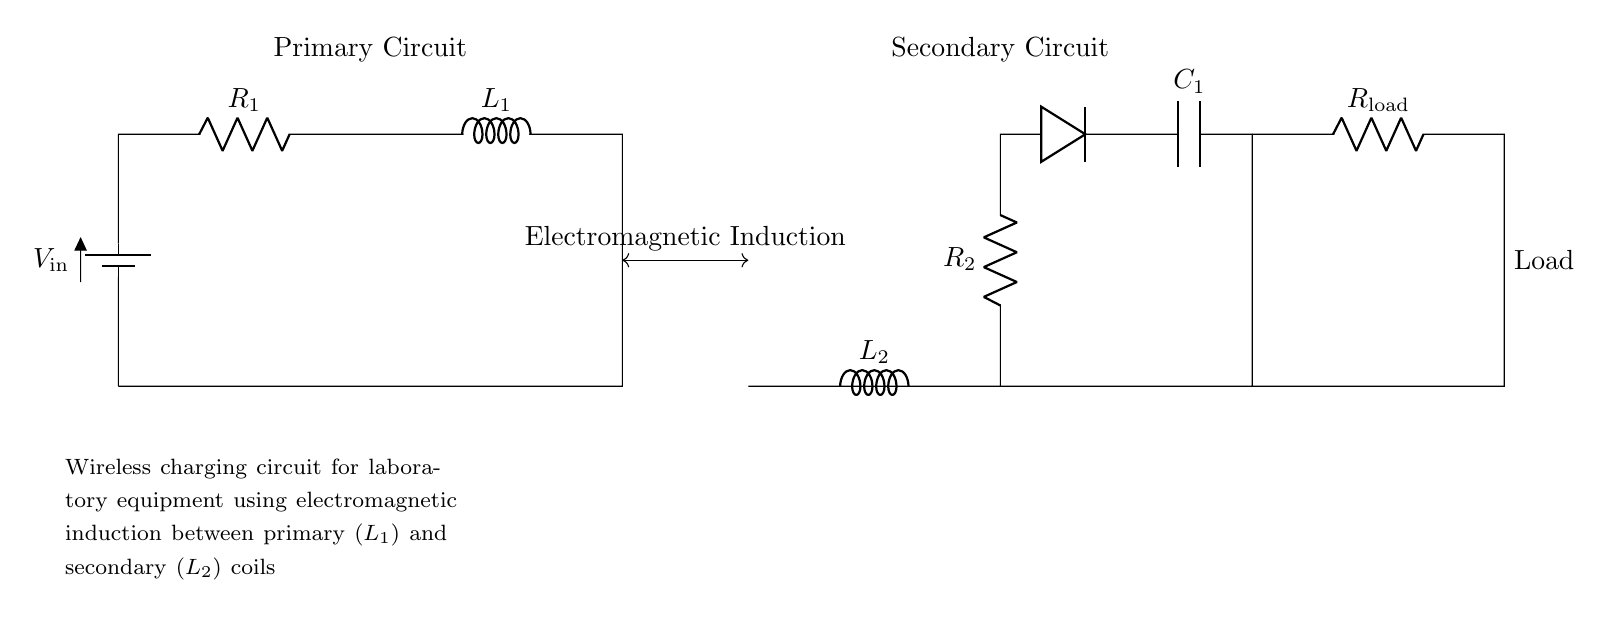What type of circuit is used for this wireless charging? The circuit is a wireless charging circuit that uses electromagnetic induction between the primary and secondary coils to transfer energy.
Answer: Wireless charging What component converts AC to DC in the secondary circuit? The diode in the secondary circuit allows current to flow in one direction, converting the alternating current induced from the secondary coil into direct current for the load.
Answer: Diode What is the role of the inductor L1 in the primary circuit? The inductor L1 in the primary circuit creates a magnetic field when current flows through it, which induces a current in the secondary coil according to Faraday's law of electromagnetic induction.
Answer: Magnetic field What does the capacitor C1 do in the secondary circuit? The capacitor C1 smooths out the rectified DC output, reducing voltage fluctuations and providing more stable power to the load.
Answer: Smoothing voltage How does the load R_load receive power in this circuit? The load R_load receives power by the electromagnetic induction process where energy is transferred from the primary coil L1 to the secondary coil L2, and then delivered to R_load after rectification by the diode and smoothing by the capacitor.
Answer: Induction process 